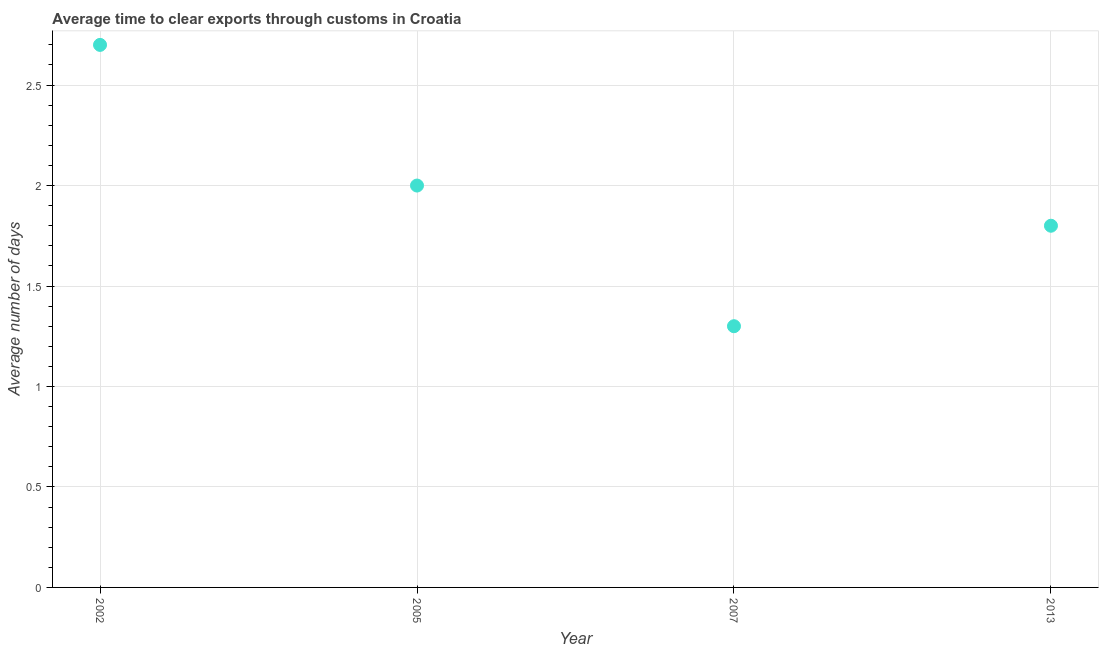What is the time to clear exports through customs in 2005?
Provide a short and direct response. 2. Across all years, what is the maximum time to clear exports through customs?
Your answer should be compact. 2.7. In which year was the time to clear exports through customs maximum?
Make the answer very short. 2002. What is the difference between the time to clear exports through customs in 2002 and 2007?
Offer a very short reply. 1.4. What is the average time to clear exports through customs per year?
Offer a very short reply. 1.95. What is the ratio of the time to clear exports through customs in 2002 to that in 2005?
Offer a very short reply. 1.35. Is the difference between the time to clear exports through customs in 2005 and 2007 greater than the difference between any two years?
Give a very brief answer. No. What is the difference between the highest and the second highest time to clear exports through customs?
Provide a short and direct response. 0.7. What is the difference between the highest and the lowest time to clear exports through customs?
Offer a very short reply. 1.4. How many dotlines are there?
Your answer should be compact. 1. How many years are there in the graph?
Offer a very short reply. 4. What is the difference between two consecutive major ticks on the Y-axis?
Offer a very short reply. 0.5. Does the graph contain grids?
Provide a succinct answer. Yes. What is the title of the graph?
Provide a succinct answer. Average time to clear exports through customs in Croatia. What is the label or title of the Y-axis?
Offer a very short reply. Average number of days. What is the Average number of days in 2013?
Your answer should be very brief. 1.8. What is the difference between the Average number of days in 2002 and 2007?
Give a very brief answer. 1.4. What is the difference between the Average number of days in 2002 and 2013?
Your answer should be very brief. 0.9. What is the difference between the Average number of days in 2005 and 2013?
Offer a very short reply. 0.2. What is the ratio of the Average number of days in 2002 to that in 2005?
Ensure brevity in your answer.  1.35. What is the ratio of the Average number of days in 2002 to that in 2007?
Ensure brevity in your answer.  2.08. What is the ratio of the Average number of days in 2005 to that in 2007?
Your answer should be very brief. 1.54. What is the ratio of the Average number of days in 2005 to that in 2013?
Make the answer very short. 1.11. What is the ratio of the Average number of days in 2007 to that in 2013?
Provide a short and direct response. 0.72. 